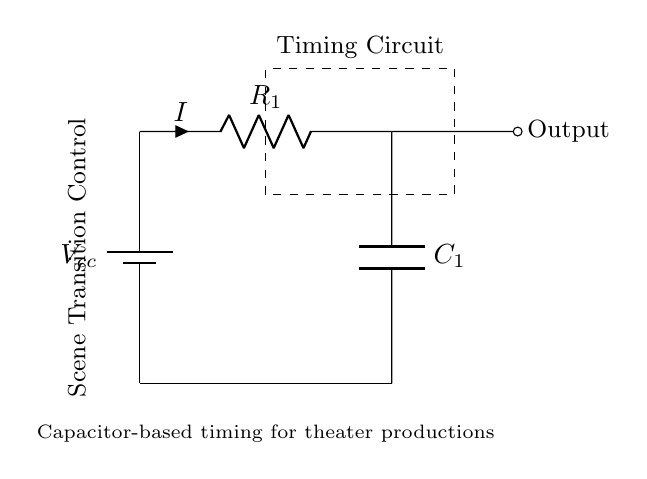What is the value of the resistance in the circuit? The circuit diagram indicates a resistor labeled R1, but the value is not specified. Thus, I can't provide a specific numerical answer.
Answer: Not specified What is the voltage source in the circuit? The diagram shows a battery labeled Vcc at the top left corner of the circuit, indicating the voltage source.
Answer: Vcc What component is responsible for timing in this circuit? The capacitor labeled C1 is the component used for timing in this resistor-capacitor circuit, as it interacts with the resistor to determine timing characteristics.
Answer: C1 How does the current flow in the circuit? The current, indicated by the arrow labeled I, flows from the positive terminal of the battery through the resistor R1 and then charges the capacitor C1 in a loop back to the negative terminal.
Answer: From battery to resistor to capacitor What is the role of the capacitor in the scene transition control? The capacitor C1 is used to store charge, which then controls the timing of how long it takes for the scene transition to occur, effectively timing the output signal based on its charge and discharge characteristics.
Answer: Timing for scene transitions What happens when the capacitor is fully charged? When the capacitor is fully charged, it will stop allowing current to flow through, which will effectively set the timing for when the scene transition output is triggered, based on the time constant determined by R1 and C1.
Answer: Stops current flow 